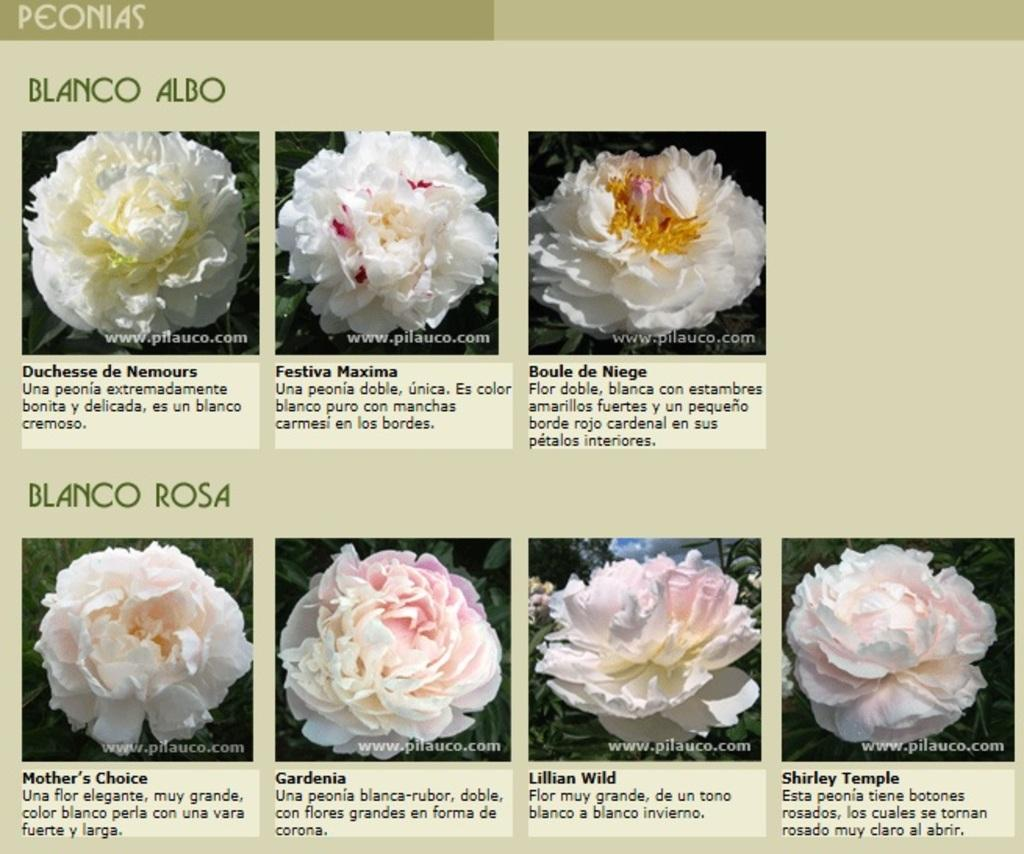What is the main object in the image? There is a slide in the image. What is depicted on the slide? The slide contains different kinds of flowers. How can the viewer identify the flowers on the slide? The names of the flowers are present below the images, along with their descriptions. What type of brass material is used to construct the slide in the image? The slide in the image is not made of brass; it is a visual representation of flowers on a slide. Can you describe the steel structure supporting the slide in the image? There is no steel structure supporting the slide in the image, as it is a visual representation of flowers on a slide. 